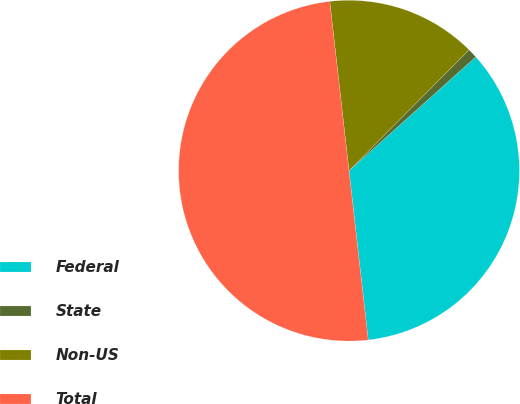Convert chart to OTSL. <chart><loc_0><loc_0><loc_500><loc_500><pie_chart><fcel>Federal<fcel>State<fcel>Non-US<fcel>Total<nl><fcel>34.84%<fcel>0.91%<fcel>14.25%<fcel>50.0%<nl></chart> 